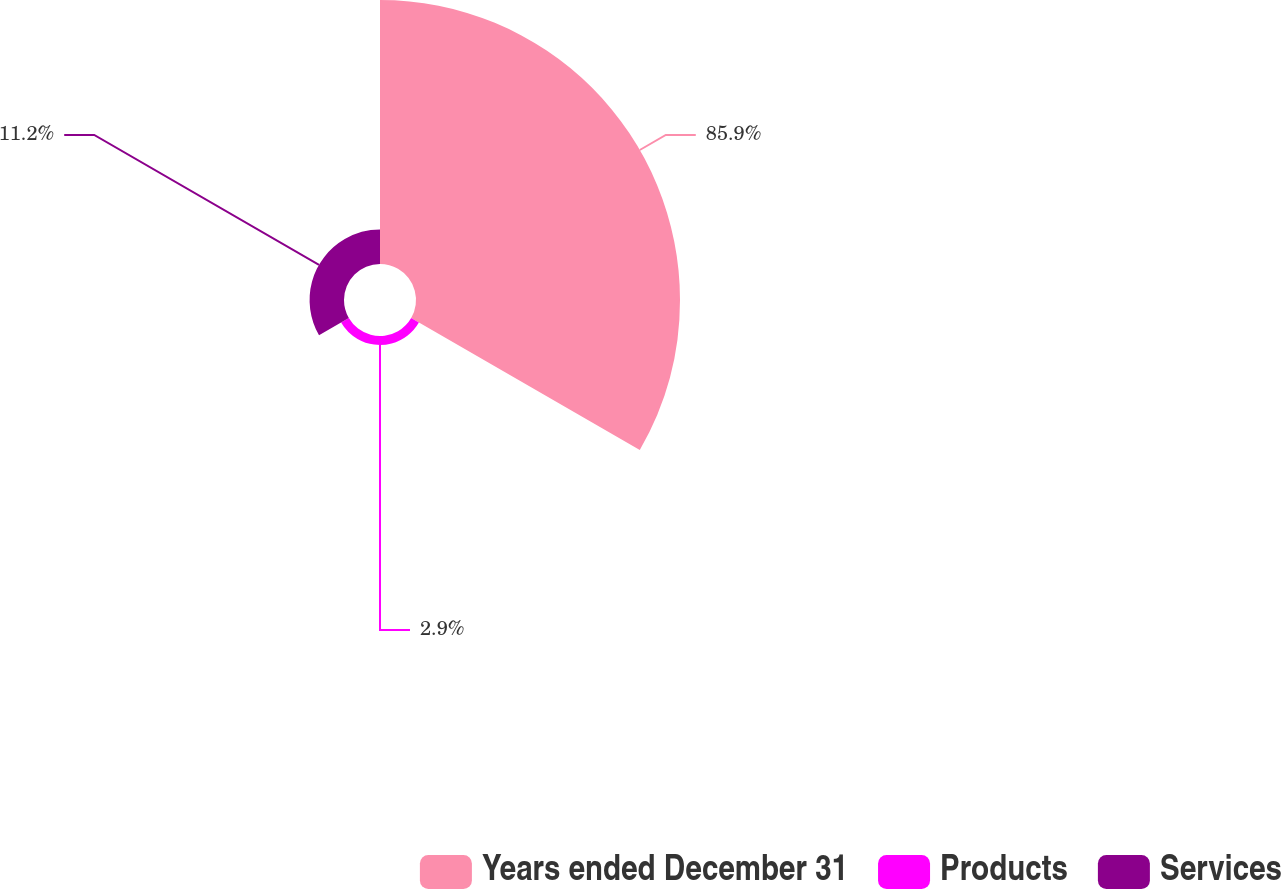<chart> <loc_0><loc_0><loc_500><loc_500><pie_chart><fcel>Years ended December 31<fcel>Products<fcel>Services<nl><fcel>85.9%<fcel>2.9%<fcel>11.2%<nl></chart> 